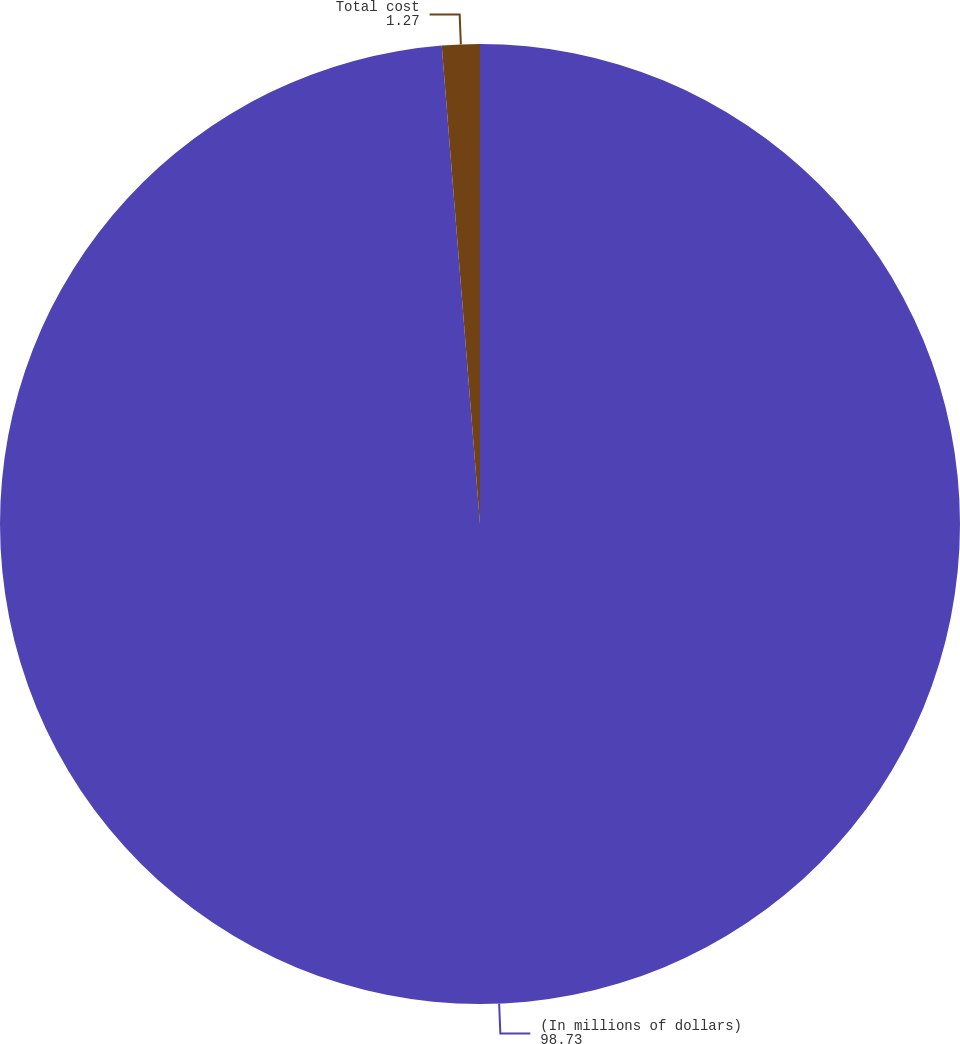<chart> <loc_0><loc_0><loc_500><loc_500><pie_chart><fcel>(In millions of dollars)<fcel>Total cost<nl><fcel>98.73%<fcel>1.27%<nl></chart> 